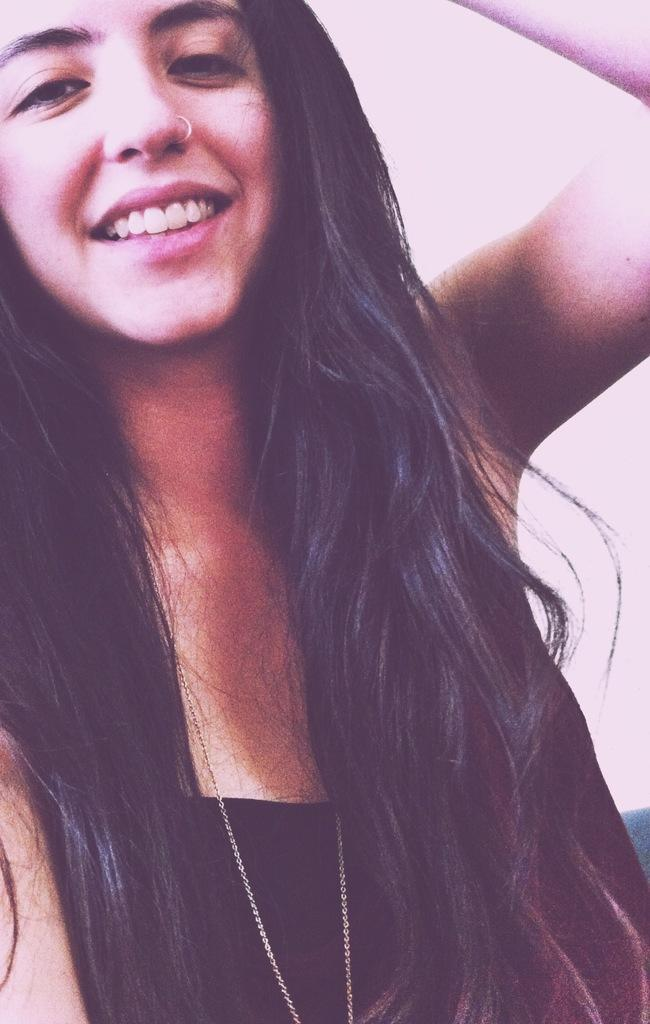What is the main subject of the image? There is a person in the image. What can be seen in the background of the image? The background of the image is white. Can you see any fairies flying around the person in the image? No, there are no fairies present in the image. What type of bird is sitting on the person's shoulder in the image? There is no bird present in the image. 